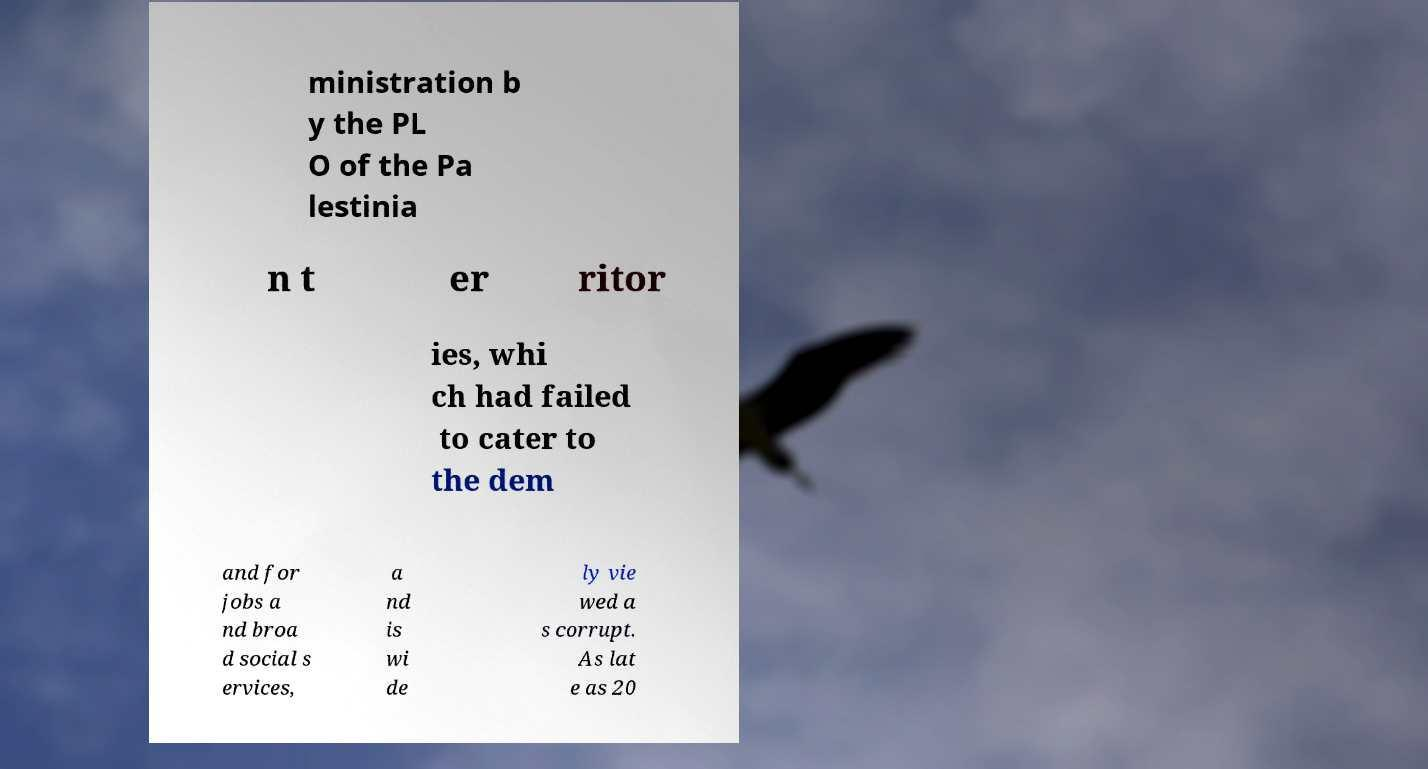What messages or text are displayed in this image? I need them in a readable, typed format. ministration b y the PL O of the Pa lestinia n t er ritor ies, whi ch had failed to cater to the dem and for jobs a nd broa d social s ervices, a nd is wi de ly vie wed a s corrupt. As lat e as 20 